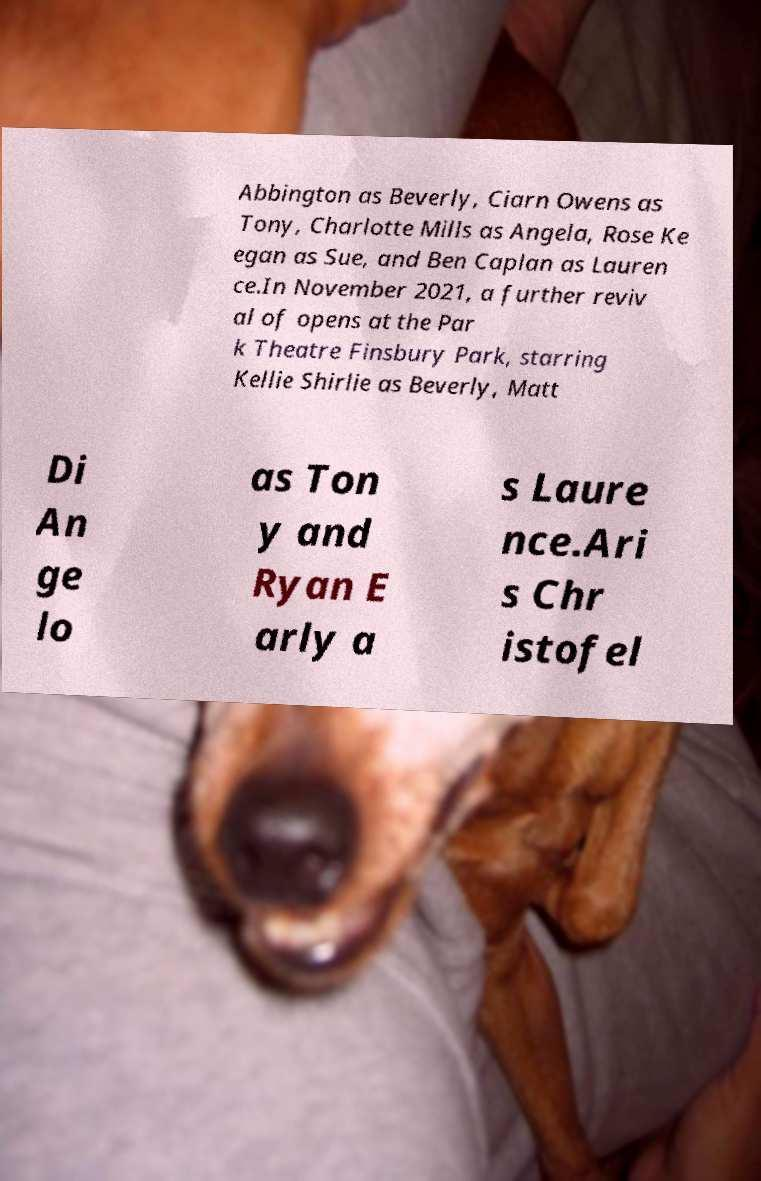Please identify and transcribe the text found in this image. Abbington as Beverly, Ciarn Owens as Tony, Charlotte Mills as Angela, Rose Ke egan as Sue, and Ben Caplan as Lauren ce.In November 2021, a further reviv al of opens at the Par k Theatre Finsbury Park, starring Kellie Shirlie as Beverly, Matt Di An ge lo as Ton y and Ryan E arly a s Laure nce.Ari s Chr istofel 